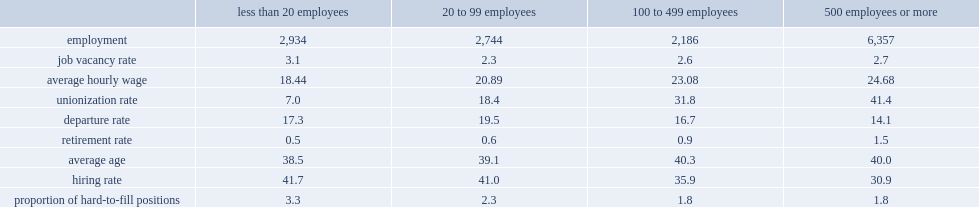What were the average hourly wages($) in locations with 500 or more employees and in locations with fewer than 20 employees respectively? 24.68 18.44. What were the hiring rates(%) in locations with 500 or more employees and in locations with fewer than 20 employees respectively? 30.9 41.7. What were the average age (years) of employees in locations with 500 or more employees was 40 years old and in the smallest locations respectively? 40.0 38.5. 